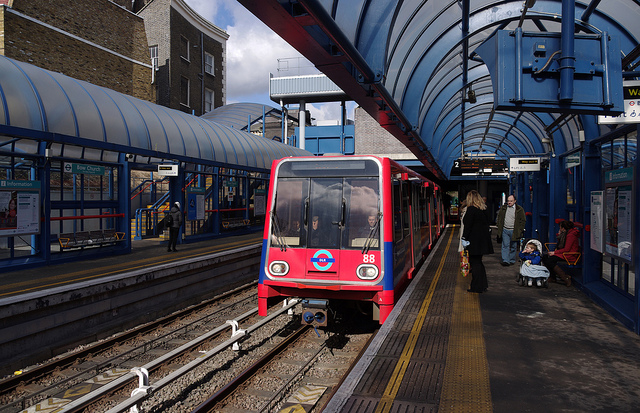Identify and read out the text in this image. 2 